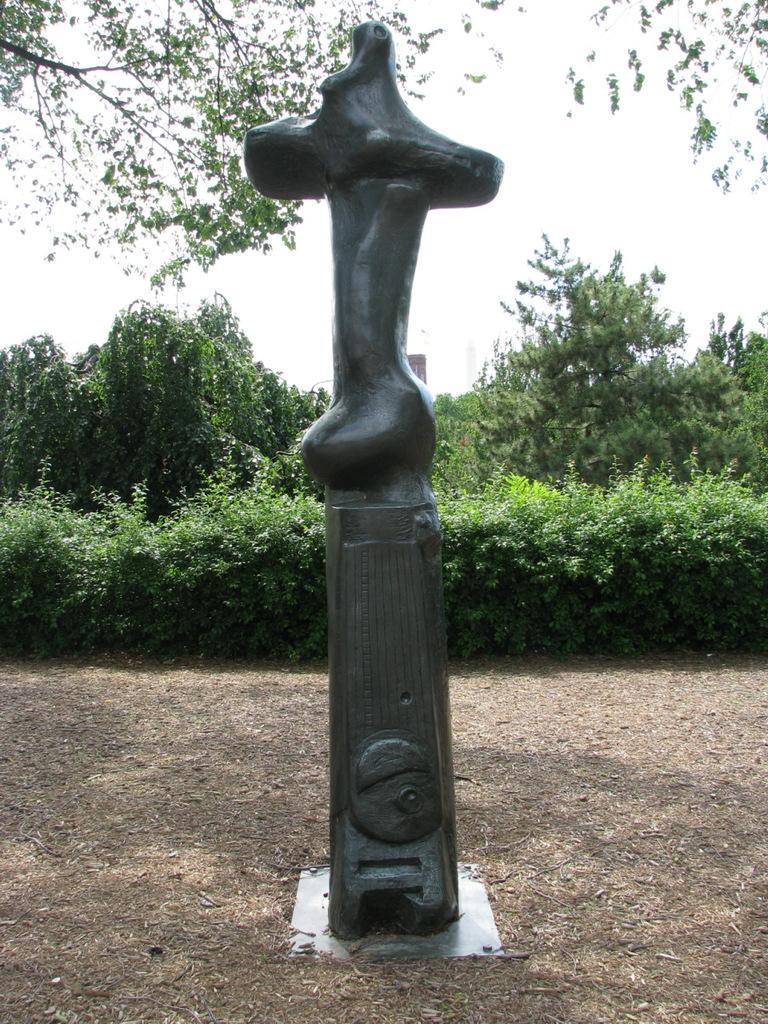Describe this image in one or two sentences. There is a statue of an object which is black in color is placed on a ground and there are trees in the background. 